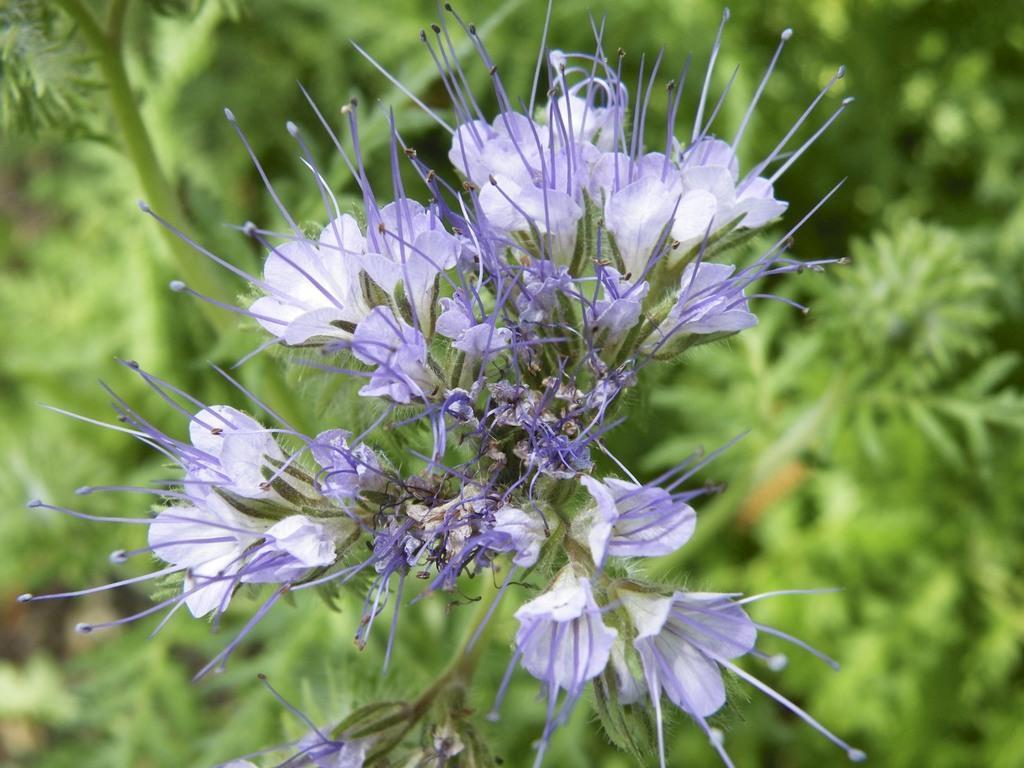Can you describe this image briefly? In this picture there are purple flowers on the plant. At the back there are plants. 